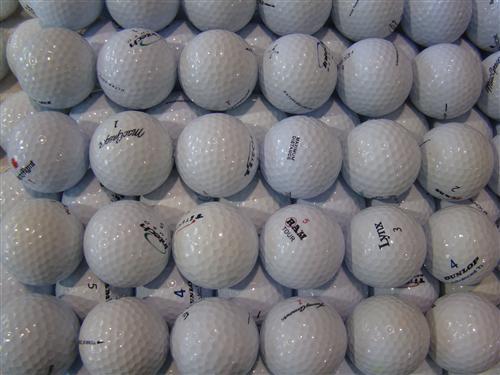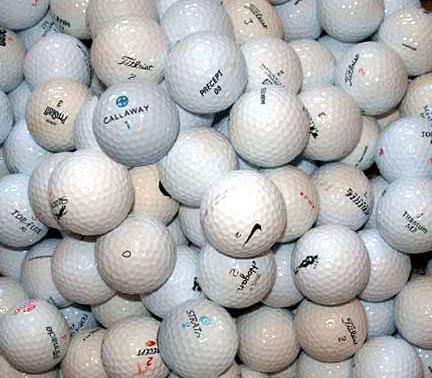The first image is the image on the left, the second image is the image on the right. For the images displayed, is the sentence "Some of the balls are sitting in tubs." factually correct? Answer yes or no. No. The first image is the image on the left, the second image is the image on the right. For the images displayed, is the sentence "An image shows many golf balls piled into a squarish tub container." factually correct? Answer yes or no. No. 